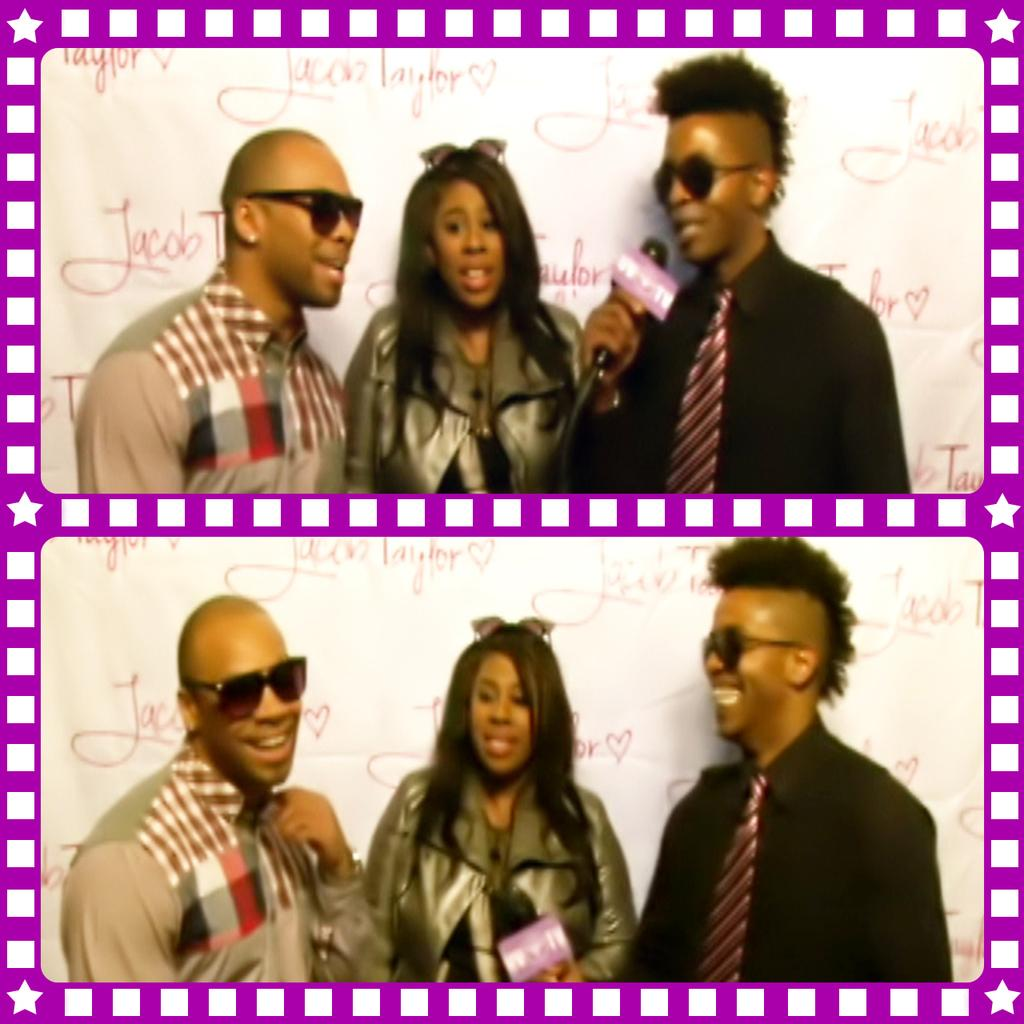What type of artwork is the image? The image is a collage. How many pictures are included in the collage? There are two pictures in the collage. What subjects are featured in each picture? Each picture contains a man and a woman. What color is the stocking on the man's leg in the image? There is no stocking visible on any man's leg in the image, as the provided facts do not mention stockings or legs. 